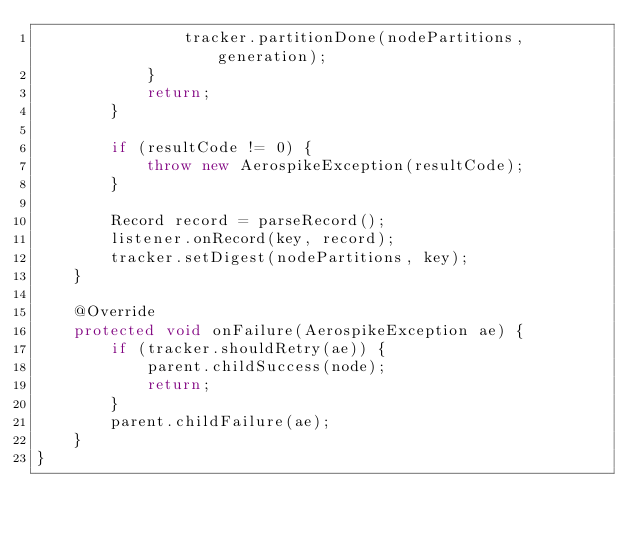Convert code to text. <code><loc_0><loc_0><loc_500><loc_500><_Java_>				tracker.partitionDone(nodePartitions, generation);
			}
			return;
		}

		if (resultCode != 0) {
			throw new AerospikeException(resultCode);
		}

		Record record = parseRecord();
		listener.onRecord(key, record);
		tracker.setDigest(nodePartitions, key);
	}

	@Override
	protected void onFailure(AerospikeException ae) {
		if (tracker.shouldRetry(ae)) {
			parent.childSuccess(node);
			return;
		}
		parent.childFailure(ae);
	}
}
</code> 